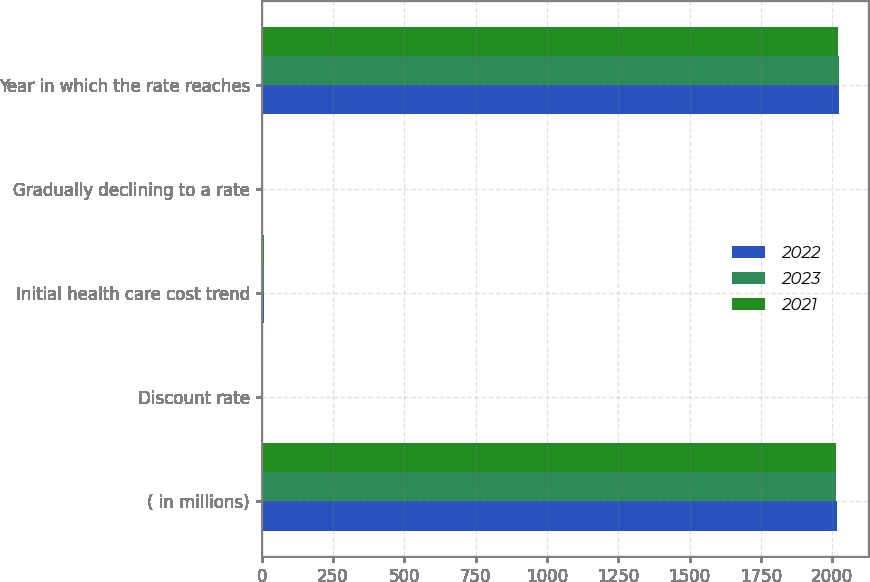<chart> <loc_0><loc_0><loc_500><loc_500><stacked_bar_chart><ecel><fcel>( in millions)<fcel>Discount rate<fcel>Initial health care cost trend<fcel>Gradually declining to a rate<fcel>Year in which the rate reaches<nl><fcel>2022<fcel>2015<fcel>4.22<fcel>7<fcel>5<fcel>2023<nl><fcel>2023<fcel>2014<fcel>5.03<fcel>7.33<fcel>5<fcel>2022<nl><fcel>2021<fcel>2013<fcel>4.02<fcel>7.67<fcel>5<fcel>2021<nl></chart> 